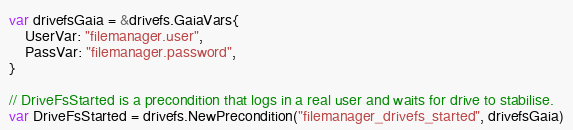<code> <loc_0><loc_0><loc_500><loc_500><_Go_>var drivefsGaia = &drivefs.GaiaVars{
	UserVar: "filemanager.user",
	PassVar: "filemanager.password",
}

// DriveFsStarted is a precondition that logs in a real user and waits for drive to stabilise.
var DriveFsStarted = drivefs.NewPrecondition("filemanager_drivefs_started", drivefsGaia)
</code> 